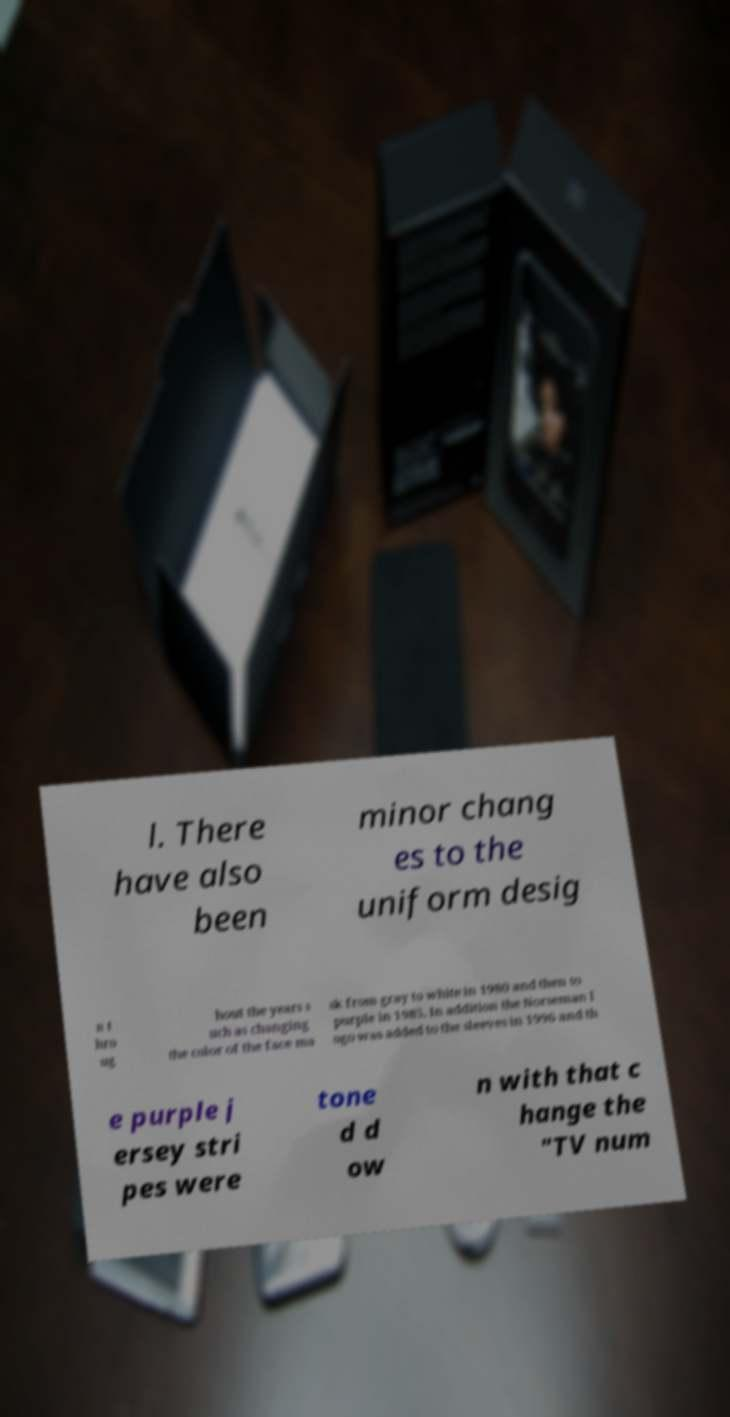Please identify and transcribe the text found in this image. l. There have also been minor chang es to the uniform desig n t hro ug hout the years s uch as changing the color of the face ma sk from gray to white in 1980 and then to purple in 1985. In addition the Norseman l ogo was added to the sleeves in 1996 and th e purple j ersey stri pes were tone d d ow n with that c hange the "TV num 